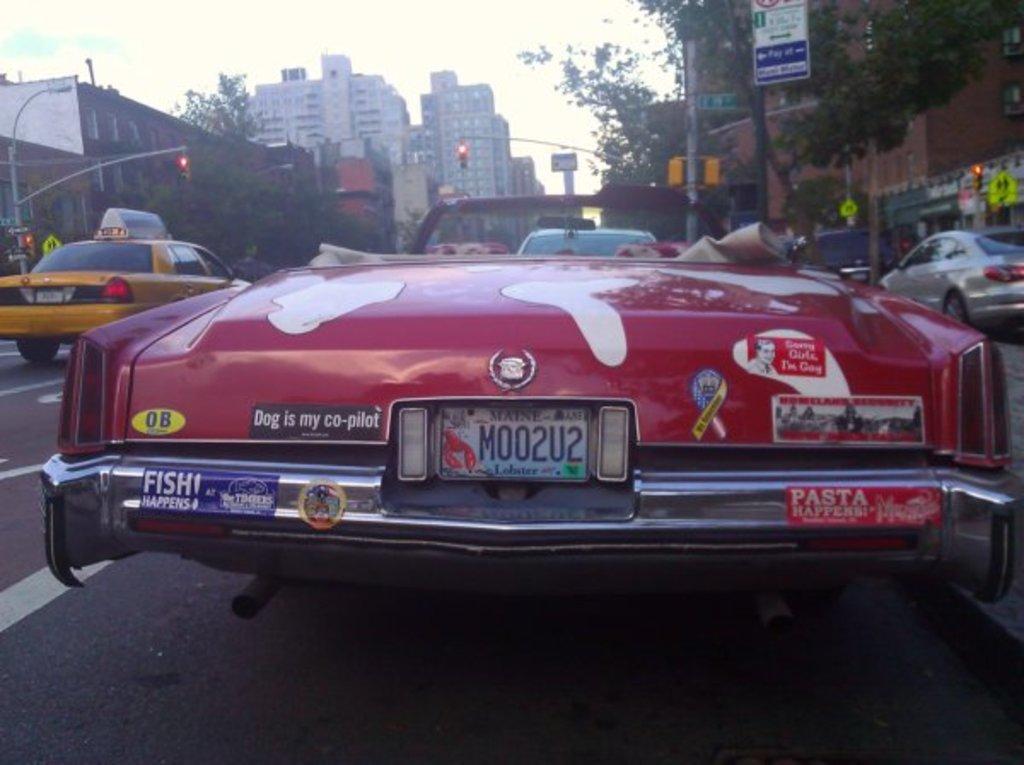What is the license plate number?
Your response must be concise. M002u2. According to the bumper sticker, who is the co-pilot?
Offer a very short reply. Dog. 